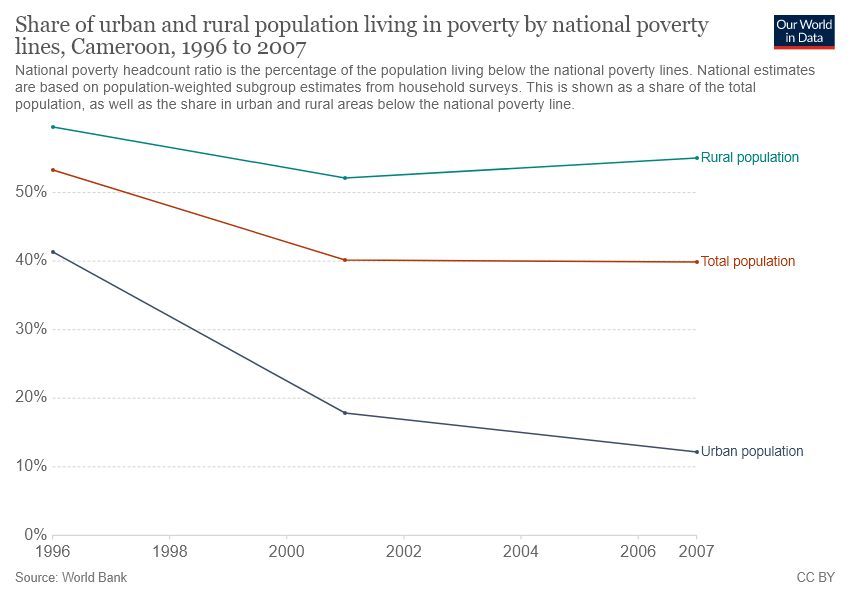Give some essential details in this illustration. For how many years was the urban population living under poverty, where more than 20% of the population was living in poverty, between 2021 and 2030? The rural population in Cameroon was living in poverty in the maximum year of 1996. 